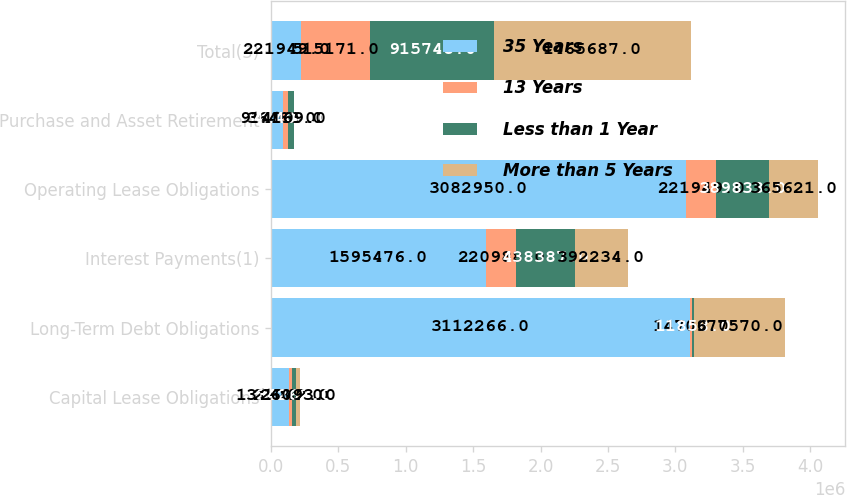<chart> <loc_0><loc_0><loc_500><loc_500><stacked_bar_chart><ecel><fcel>Capital Lease Obligations<fcel>Long-Term Debt Obligations<fcel>Interest Payments(1)<fcel>Operating Lease Obligations<fcel>Purchase and Asset Retirement<fcel>Total(3)<nl><fcel>35 Years<fcel>131687<fcel>3.11227e+06<fcel>1.59548e+06<fcel>3.08295e+06<fcel>91409<fcel>221949<nl><fcel>13 Years<fcel>21042<fcel>14709<fcel>220988<fcel>221949<fcel>36483<fcel>515171<nl><fcel>Less than 1 Year<fcel>34262<fcel>11858<fcel>438387<fcel>389833<fcel>41408<fcel>915748<nl><fcel>More than 5 Years<fcel>26093<fcel>677570<fcel>392234<fcel>365621<fcel>4169<fcel>1.46569e+06<nl></chart> 